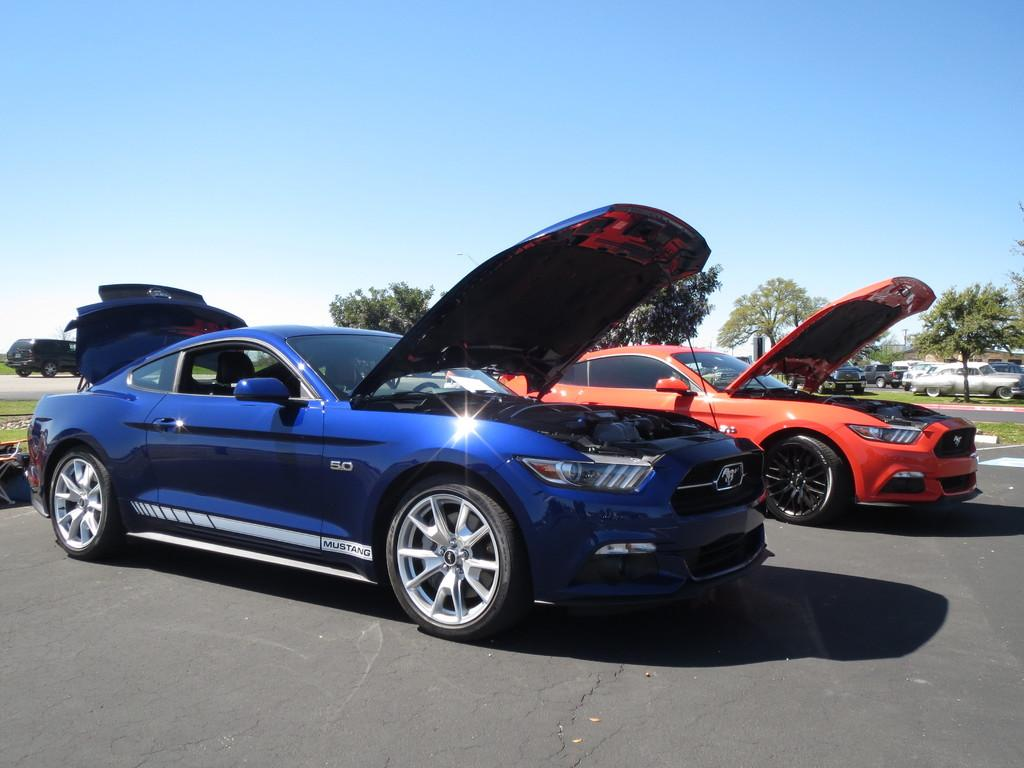What are the main subjects in the center of the image? There are two cars in the center of the image. Where are the cars located? The cars are on the road. What can be seen in the background of the image? There are trees and other vehicles visible in the background. What teaching method is being used by the truck in the image? There is no truck present in the image, so it is not possible to determine any teaching methods being used. 